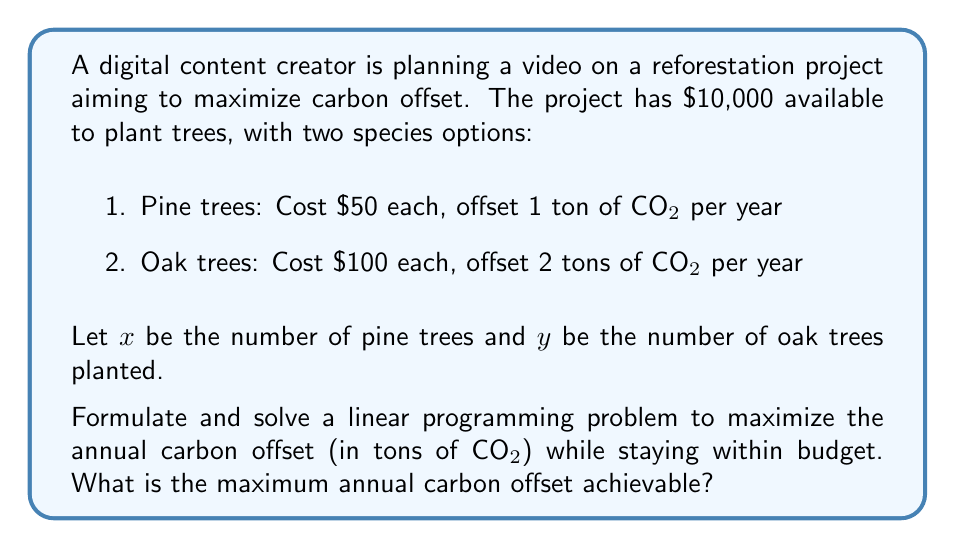Can you solve this math problem? To solve this linear programming problem, we'll follow these steps:

1. Define the objective function
2. Identify constraints
3. Graph the feasible region
4. Find the optimal solution

Step 1: Objective function
We want to maximize the total carbon offset:
$$ Z = x + 2y $$
Where $x$ is the number of pine trees (1 ton CO₂/year each) and $y$ is the number of oak trees (2 tons CO₂/year each).

Step 2: Constraints
Budget constraint: $50x + 100y \leq 10000$
Non-negativity: $x \geq 0, y \geq 0$

Step 3: Graph the feasible region
We'll graph the budget constraint:
$50x + 100y = 10000$
$x$-intercept: (200, 0)
$y$-intercept: (0, 100)

[asy]
size(200);
import graph;

xaxis("x (Pine trees)", Arrow);
yaxis("y (Oak trees)", Arrow);

draw((0,100)--(200,0), blue);
fill((0,0)--(0,100)--(200,0)--cycle, paleblue);

label("Feasible Region", (50,25), SE);
label("50x + 100y = 10000", (100,50), NW);

dot((200,0));
dot((0,100));
label("(200, 0)", (200,0), SE);
label("(0, 100)", (0,100), NW);
[/asy]

Step 4: Find the optimal solution
In linear programming, the optimal solution is always at a corner point of the feasible region. We'll evaluate the objective function at each corner point:

(0, 0): $Z = 0 + 2(0) = 0$
(200, 0): $Z = 200 + 2(0) = 200$
(0, 100): $Z = 0 + 2(100) = 200$

The optimal solution occurs at both (200, 0) and (0, 100), yielding a maximum carbon offset of 200 tons of CO₂ per year.
Answer: The maximum annual carbon offset achievable is 200 tons of CO₂. 